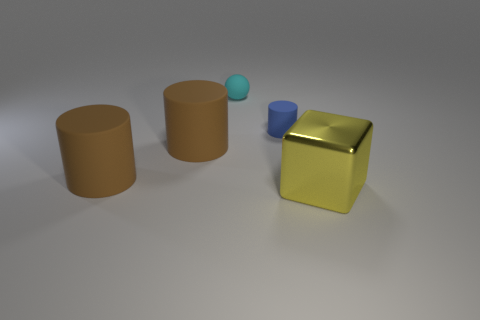Is there any significance to the color choices for the objects in the image? Color choices in visual design can be quite impactful, conveying subtle messages or emotions. In this image, the use of earthy browns and soft metallic gold for the larger objects projects a sense of groundedness and value, while the contrasting pop of cyan blue adds a playful and modern twist. These color choices might suggest a narrative of tradition versus modernity, or stability contrasted with creativity. 